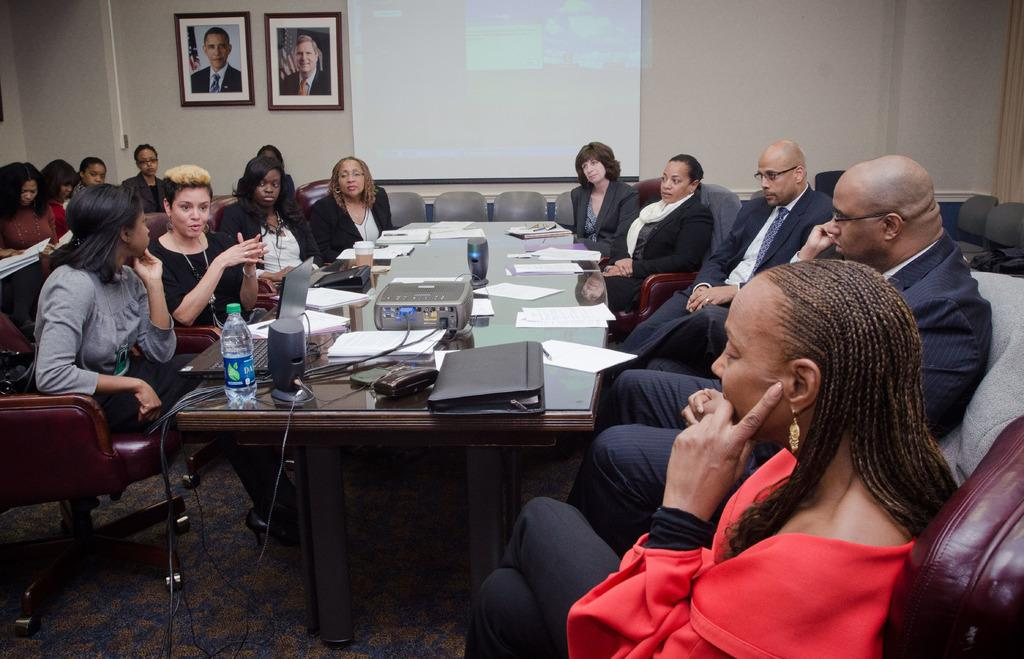What type of structure can be seen in the image? There is a wall in the image. What device is present for displaying visual content? There is a screen in the image. Are there any decorative items visible in the image? Yes, there are photo frames in the image. What are the people in the image doing? There are people sitting on chairs in the image. What piece of furniture is present in the image? There is a table in the image. What device is placed on the table? There is a projector on the table. What items can be seen on the table besides the projector? There is a bottle, files, and papers on the table. Where is the calendar located in the image? There is no calendar present in the image. What type of coil is being used by the people sitting on chairs? There is no coil present in the image, and the people sitting on chairs are not using any coils. What type of corn can be seen growing on the table? There is no corn present in the image; the table contains a projector, a bottle, files, and papers. 